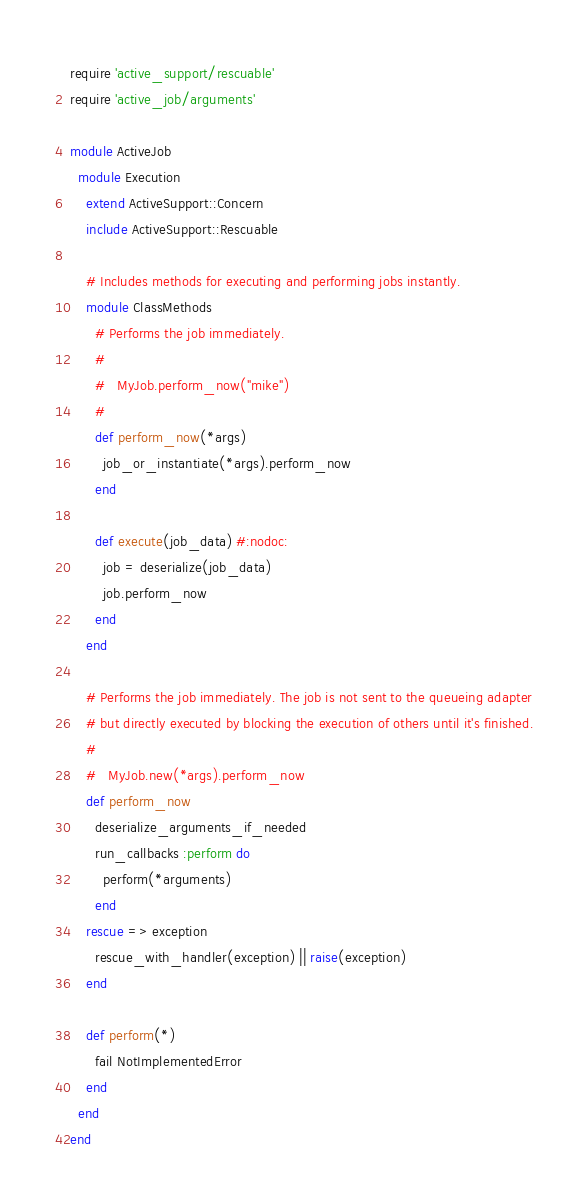<code> <loc_0><loc_0><loc_500><loc_500><_Ruby_>require 'active_support/rescuable'
require 'active_job/arguments'

module ActiveJob
  module Execution
    extend ActiveSupport::Concern
    include ActiveSupport::Rescuable

    # Includes methods for executing and performing jobs instantly.
    module ClassMethods
      # Performs the job immediately.
      #
      #   MyJob.perform_now("mike")
      #
      def perform_now(*args)
        job_or_instantiate(*args).perform_now
      end

      def execute(job_data) #:nodoc:
        job = deserialize(job_data)
        job.perform_now
      end
    end

    # Performs the job immediately. The job is not sent to the queueing adapter
    # but directly executed by blocking the execution of others until it's finished.
    #
    #   MyJob.new(*args).perform_now
    def perform_now
      deserialize_arguments_if_needed
      run_callbacks :perform do
        perform(*arguments)
      end
    rescue => exception
      rescue_with_handler(exception) || raise(exception)
    end

    def perform(*)
      fail NotImplementedError
    end
  end
end
</code> 